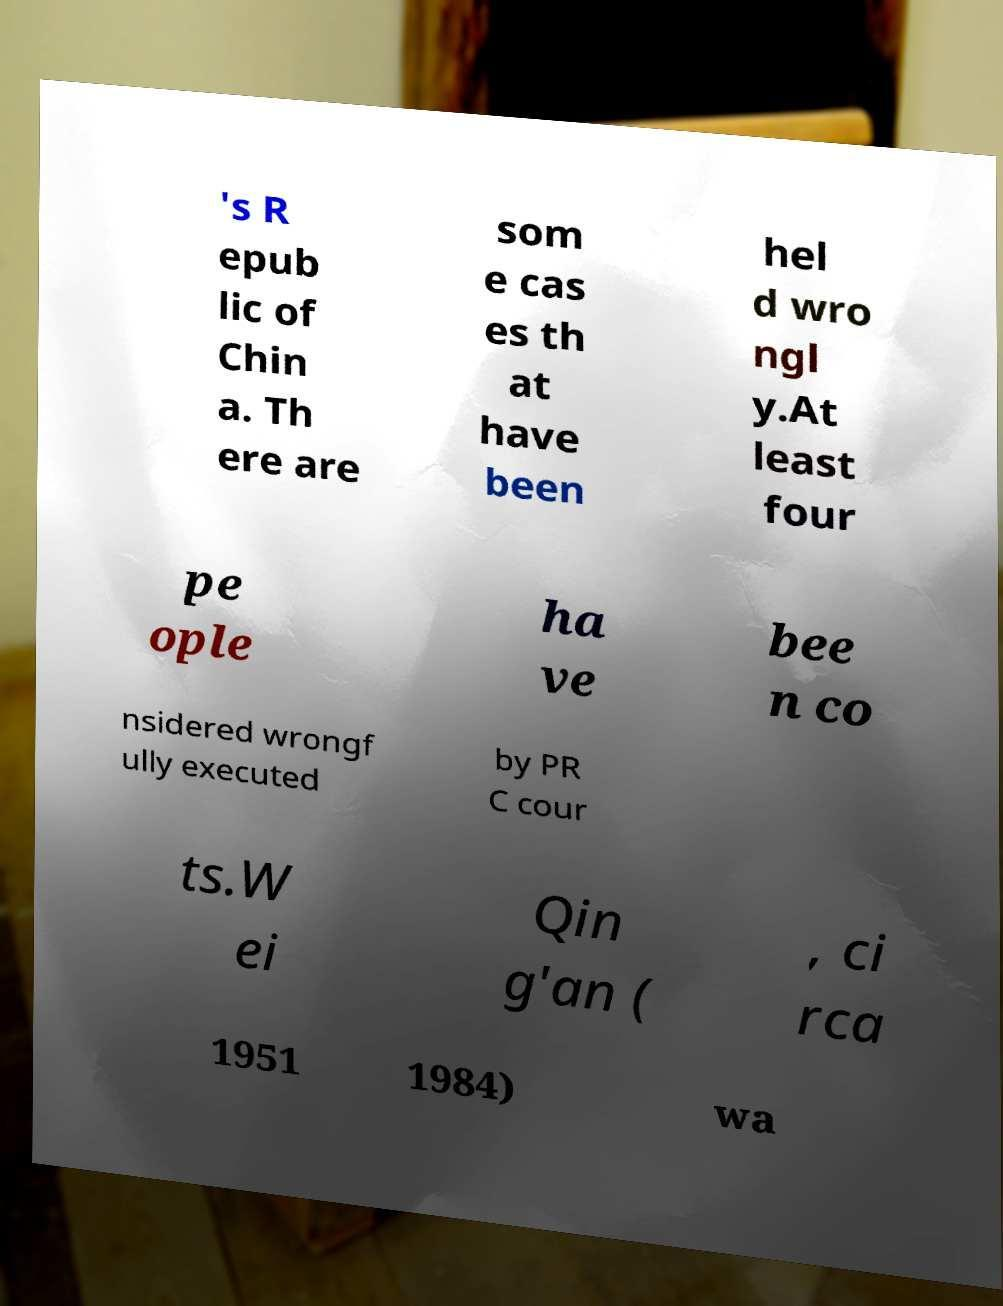Can you accurately transcribe the text from the provided image for me? 's R epub lic of Chin a. Th ere are som e cas es th at have been hel d wro ngl y.At least four pe ople ha ve bee n co nsidered wrongf ully executed by PR C cour ts.W ei Qin g'an ( , ci rca 1951 1984) wa 